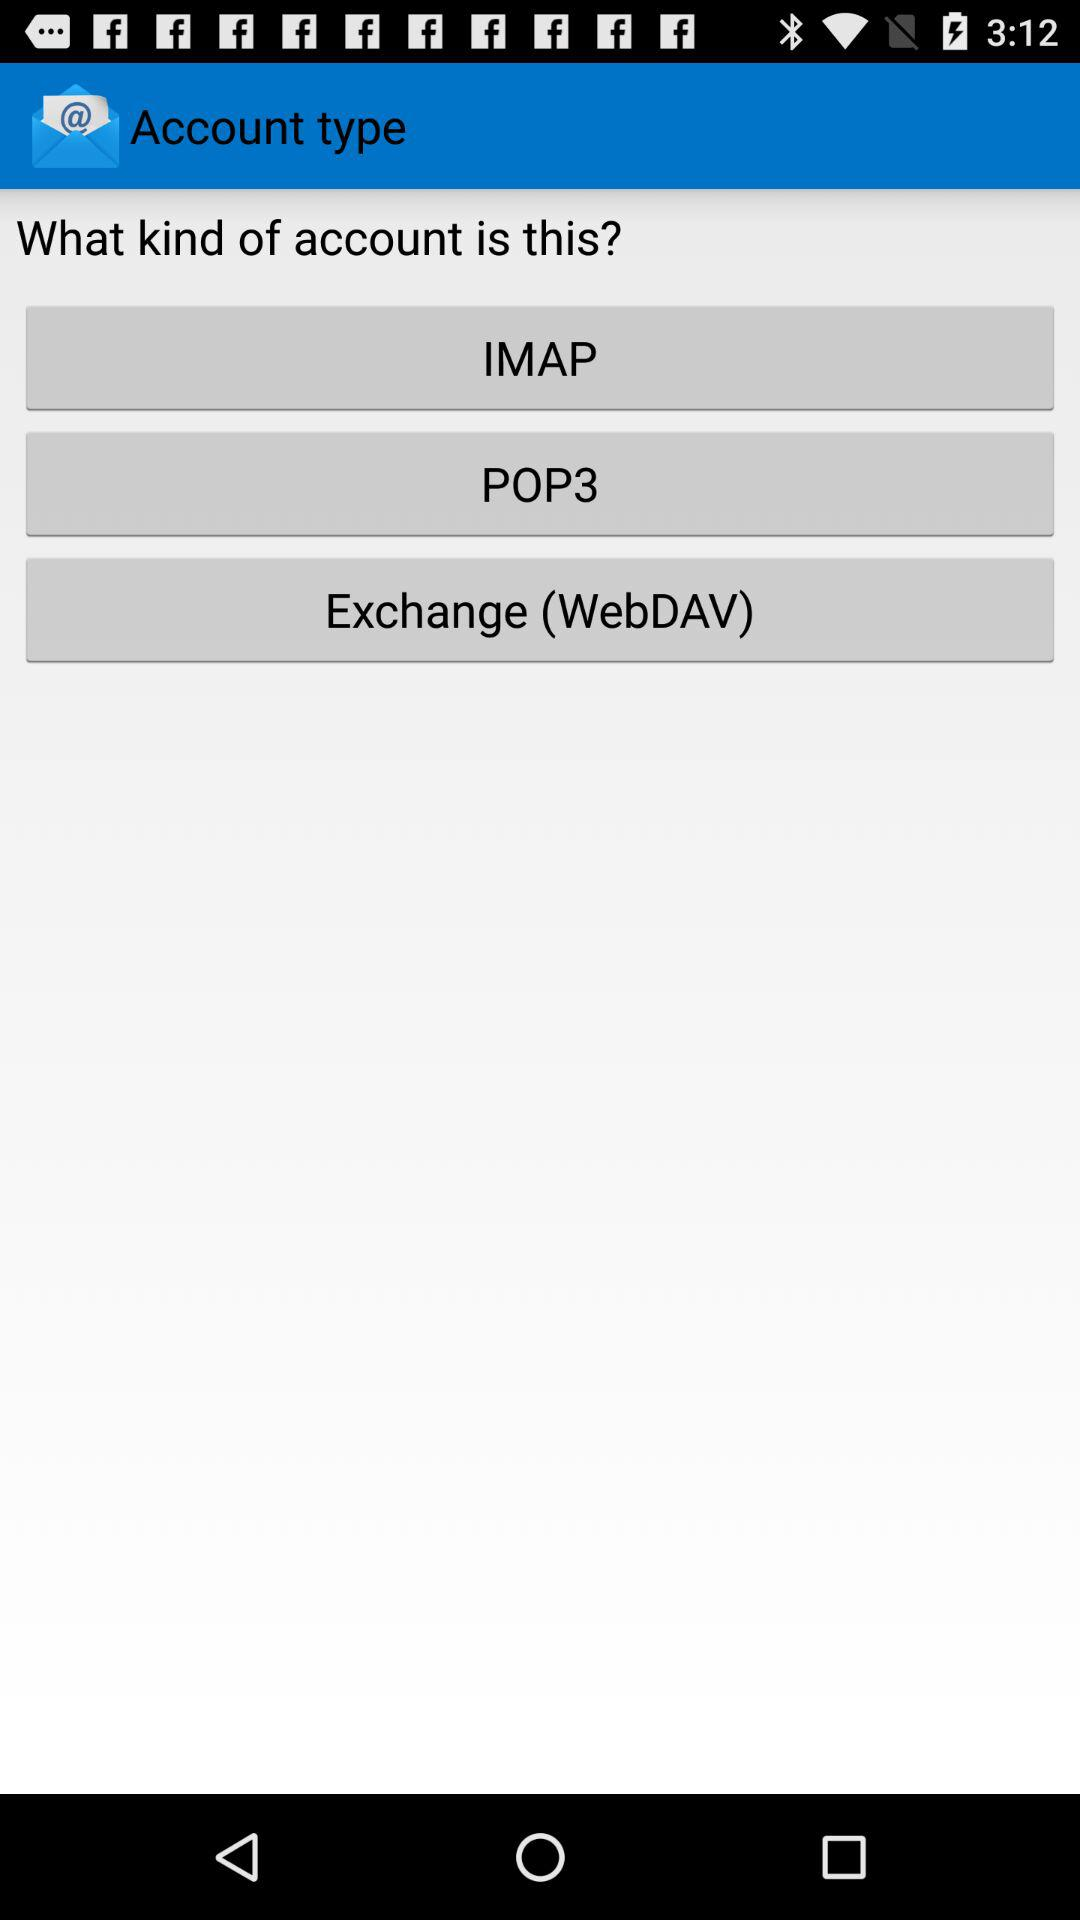How many account types are available?
Answer the question using a single word or phrase. 3 